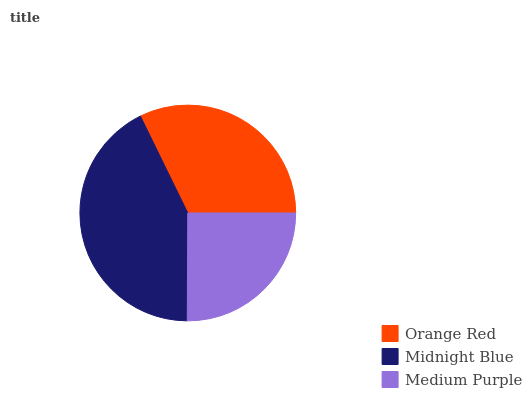Is Medium Purple the minimum?
Answer yes or no. Yes. Is Midnight Blue the maximum?
Answer yes or no. Yes. Is Midnight Blue the minimum?
Answer yes or no. No. Is Medium Purple the maximum?
Answer yes or no. No. Is Midnight Blue greater than Medium Purple?
Answer yes or no. Yes. Is Medium Purple less than Midnight Blue?
Answer yes or no. Yes. Is Medium Purple greater than Midnight Blue?
Answer yes or no. No. Is Midnight Blue less than Medium Purple?
Answer yes or no. No. Is Orange Red the high median?
Answer yes or no. Yes. Is Orange Red the low median?
Answer yes or no. Yes. Is Medium Purple the high median?
Answer yes or no. No. Is Midnight Blue the low median?
Answer yes or no. No. 